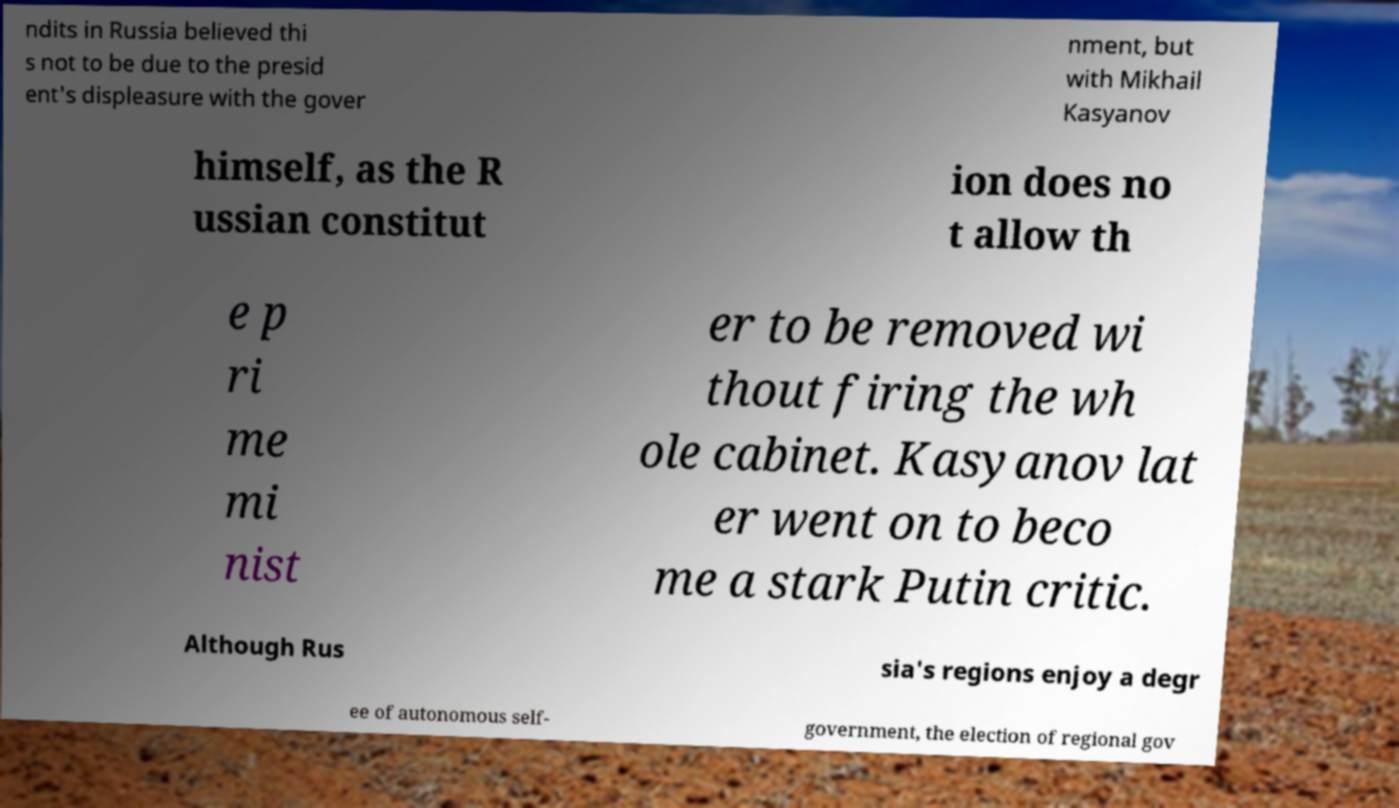Could you extract and type out the text from this image? ndits in Russia believed thi s not to be due to the presid ent's displeasure with the gover nment, but with Mikhail Kasyanov himself, as the R ussian constitut ion does no t allow th e p ri me mi nist er to be removed wi thout firing the wh ole cabinet. Kasyanov lat er went on to beco me a stark Putin critic. Although Rus sia's regions enjoy a degr ee of autonomous self- government, the election of regional gov 